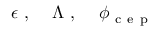Convert formula to latex. <formula><loc_0><loc_0><loc_500><loc_500>\epsilon , \quad \Lambda , \quad \phi _ { c e p }</formula> 